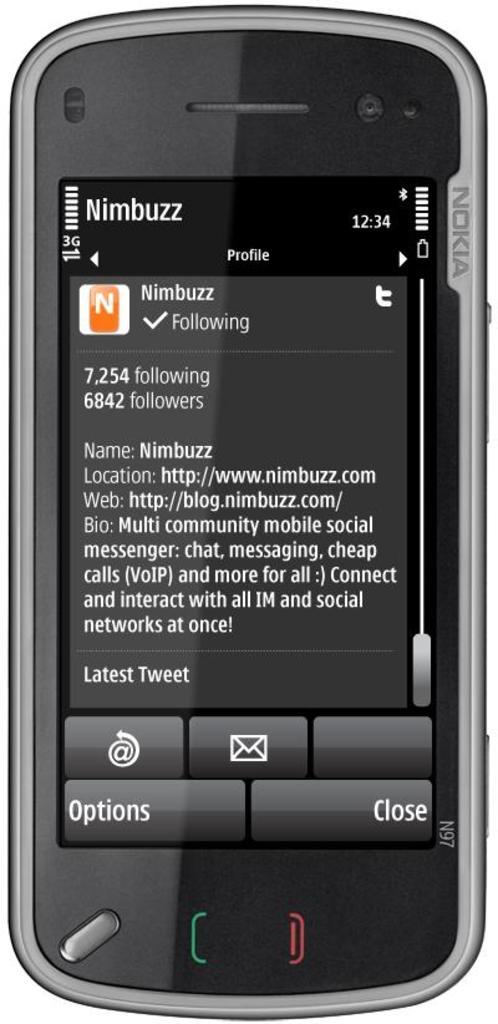<image>
Present a compact description of the photo's key features. A black phone with a profile of someone called Nimbuzz pulled up. 